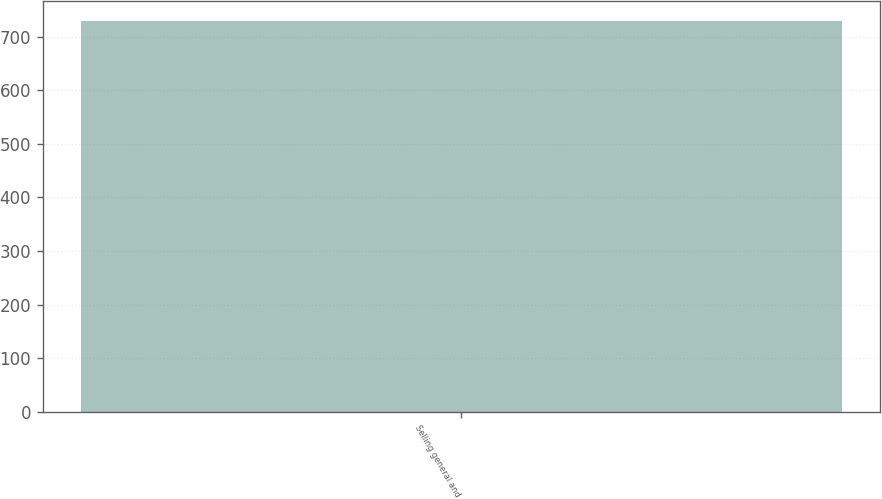Convert chart to OTSL. <chart><loc_0><loc_0><loc_500><loc_500><bar_chart><fcel>Selling general and<nl><fcel>729.1<nl></chart> 